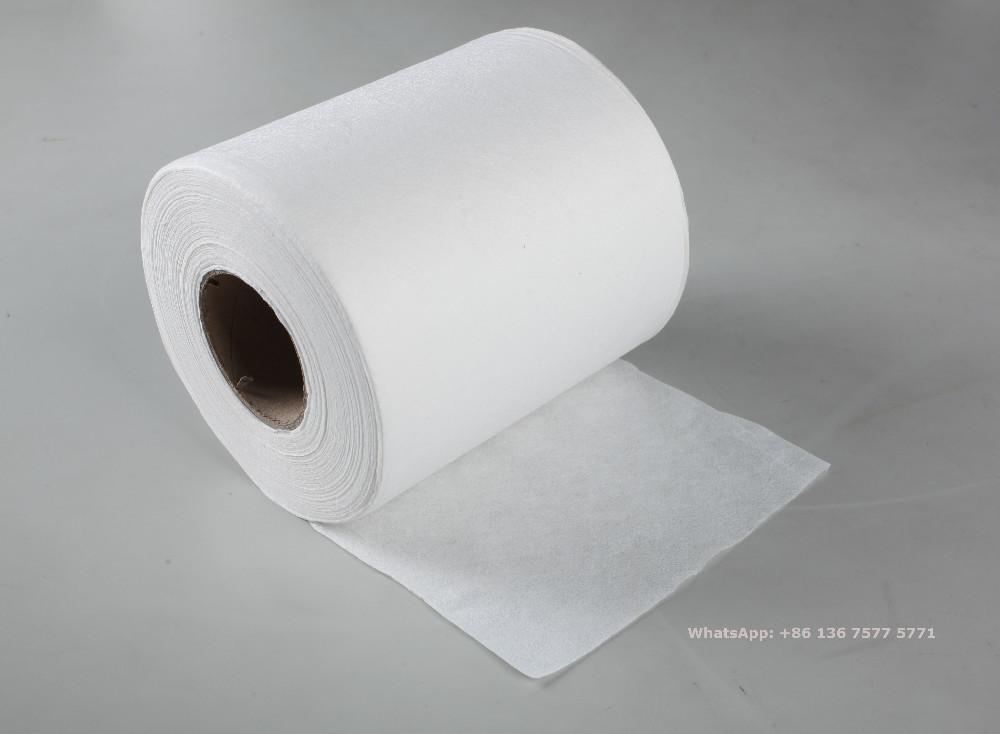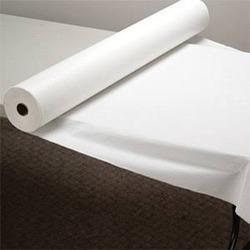The first image is the image on the left, the second image is the image on the right. For the images displayed, is the sentence "There is toilet paper with a little bit unrolled underneath on the ground." factually correct? Answer yes or no. Yes. 